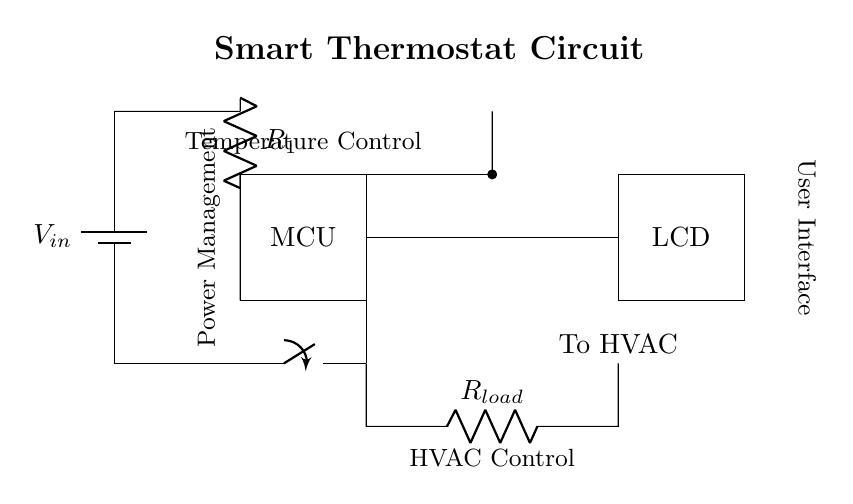What is the function of the MCU in this circuit? The MCU, or Microcontroller Unit, is responsible for processing data from the temperature sensor and controlling the operation of the HVAC system based on the detected temperature.
Answer: Processing temperature What type of component is shown at the top left of the circuit? The component shown is a battery, which is indicated by the symbol for a battery in the circuit. It serves as the power supply for the circuit.
Answer: Battery How does the temperature sensor connect to the MCU? The temperature sensor connects to the MCU through a direct wire connection (short line) that goes from the sensor to the MCU, allowing the MCU to read temperature data.
Answer: Direct wire connection What is the purpose of the relay in this circuit? The relay acts as a switch that controls the HVAC system based on the signals received from the MCU in response to temperature readings.
Answer: HVAC control What is the role of the LCD display in this setup? The LCD display provides a user interface to show the current temperature and settings, allowing users to interact with the thermostat.
Answer: User interface How many resistors are present in this circuit? There are two resistors indicated in the circuit diagram, one being a load resistor and the other being a power management resistor.
Answer: Two resistors What is the voltage supply indicated in this circuit? The voltage supply is denoted by \( V_{in} \), which provides the necessary voltage for powering the entire circuit.
Answer: V_in 